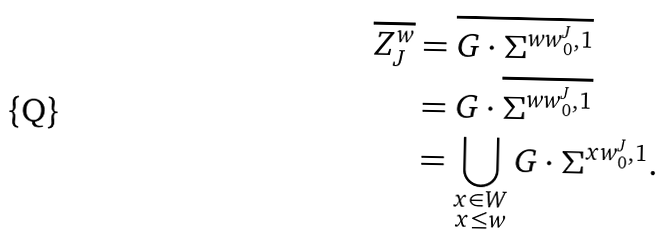Convert formula to latex. <formula><loc_0><loc_0><loc_500><loc_500>\overline { Z ^ { w } _ { J } } & = \overline { G \cdot \Sigma ^ { w w _ { 0 } ^ { J } , 1 } } \\ & = G \cdot \overline { \Sigma ^ { w w _ { 0 } ^ { J } , 1 } } \\ & = \bigcup _ { \substack { x \in W \\ x \leq w } } G \cdot \Sigma ^ { x w _ { 0 } ^ { J } , 1 } .</formula> 